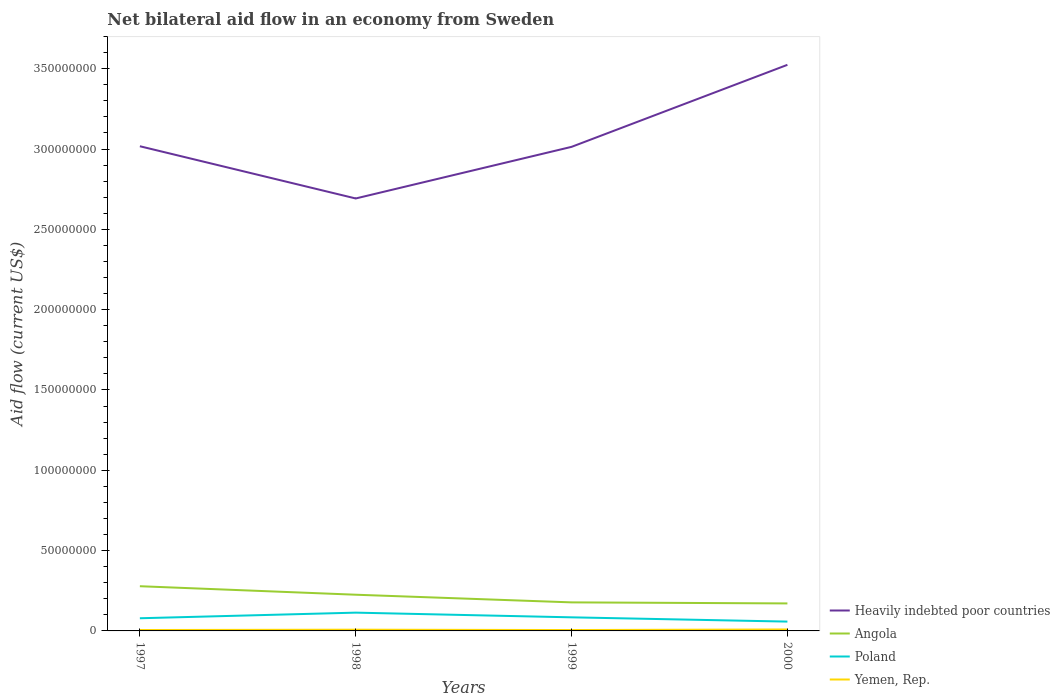Does the line corresponding to Heavily indebted poor countries intersect with the line corresponding to Angola?
Provide a succinct answer. No. Across all years, what is the maximum net bilateral aid flow in Angola?
Give a very brief answer. 1.71e+07. In which year was the net bilateral aid flow in Yemen, Rep. maximum?
Give a very brief answer. 1999. What is the total net bilateral aid flow in Angola in the graph?
Make the answer very short. 5.29e+06. What is the difference between the highest and the second highest net bilateral aid flow in Heavily indebted poor countries?
Provide a succinct answer. 8.32e+07. Is the net bilateral aid flow in Angola strictly greater than the net bilateral aid flow in Heavily indebted poor countries over the years?
Your answer should be compact. Yes. How many lines are there?
Provide a succinct answer. 4. Are the values on the major ticks of Y-axis written in scientific E-notation?
Give a very brief answer. No. Does the graph contain any zero values?
Offer a very short reply. No. Does the graph contain grids?
Keep it short and to the point. No. How are the legend labels stacked?
Offer a very short reply. Vertical. What is the title of the graph?
Your answer should be compact. Net bilateral aid flow in an economy from Sweden. What is the label or title of the X-axis?
Give a very brief answer. Years. What is the Aid flow (current US$) in Heavily indebted poor countries in 1997?
Keep it short and to the point. 3.02e+08. What is the Aid flow (current US$) of Angola in 1997?
Your answer should be compact. 2.78e+07. What is the Aid flow (current US$) in Poland in 1997?
Provide a succinct answer. 7.89e+06. What is the Aid flow (current US$) of Yemen, Rep. in 1997?
Your answer should be compact. 5.60e+05. What is the Aid flow (current US$) in Heavily indebted poor countries in 1998?
Keep it short and to the point. 2.69e+08. What is the Aid flow (current US$) of Angola in 1998?
Ensure brevity in your answer.  2.25e+07. What is the Aid flow (current US$) in Poland in 1998?
Your answer should be very brief. 1.14e+07. What is the Aid flow (current US$) in Yemen, Rep. in 1998?
Give a very brief answer. 7.70e+05. What is the Aid flow (current US$) of Heavily indebted poor countries in 1999?
Your response must be concise. 3.01e+08. What is the Aid flow (current US$) in Angola in 1999?
Ensure brevity in your answer.  1.78e+07. What is the Aid flow (current US$) of Poland in 1999?
Give a very brief answer. 8.46e+06. What is the Aid flow (current US$) in Yemen, Rep. in 1999?
Ensure brevity in your answer.  5.50e+05. What is the Aid flow (current US$) of Heavily indebted poor countries in 2000?
Provide a short and direct response. 3.52e+08. What is the Aid flow (current US$) of Angola in 2000?
Offer a terse response. 1.71e+07. What is the Aid flow (current US$) of Poland in 2000?
Your answer should be very brief. 5.81e+06. What is the Aid flow (current US$) in Yemen, Rep. in 2000?
Your answer should be very brief. 9.10e+05. Across all years, what is the maximum Aid flow (current US$) in Heavily indebted poor countries?
Your answer should be very brief. 3.52e+08. Across all years, what is the maximum Aid flow (current US$) of Angola?
Offer a terse response. 2.78e+07. Across all years, what is the maximum Aid flow (current US$) in Poland?
Offer a very short reply. 1.14e+07. Across all years, what is the maximum Aid flow (current US$) of Yemen, Rep.?
Ensure brevity in your answer.  9.10e+05. Across all years, what is the minimum Aid flow (current US$) of Heavily indebted poor countries?
Your answer should be compact. 2.69e+08. Across all years, what is the minimum Aid flow (current US$) in Angola?
Provide a succinct answer. 1.71e+07. Across all years, what is the minimum Aid flow (current US$) in Poland?
Your response must be concise. 5.81e+06. Across all years, what is the minimum Aid flow (current US$) in Yemen, Rep.?
Make the answer very short. 5.50e+05. What is the total Aid flow (current US$) in Heavily indebted poor countries in the graph?
Ensure brevity in your answer.  1.22e+09. What is the total Aid flow (current US$) in Angola in the graph?
Keep it short and to the point. 8.53e+07. What is the total Aid flow (current US$) of Poland in the graph?
Provide a succinct answer. 3.35e+07. What is the total Aid flow (current US$) of Yemen, Rep. in the graph?
Make the answer very short. 2.79e+06. What is the difference between the Aid flow (current US$) of Heavily indebted poor countries in 1997 and that in 1998?
Offer a very short reply. 3.25e+07. What is the difference between the Aid flow (current US$) of Angola in 1997 and that in 1998?
Ensure brevity in your answer.  5.29e+06. What is the difference between the Aid flow (current US$) of Poland in 1997 and that in 1998?
Your answer should be very brief. -3.49e+06. What is the difference between the Aid flow (current US$) in Yemen, Rep. in 1997 and that in 1998?
Provide a short and direct response. -2.10e+05. What is the difference between the Aid flow (current US$) of Angola in 1997 and that in 1999?
Keep it short and to the point. 1.01e+07. What is the difference between the Aid flow (current US$) of Poland in 1997 and that in 1999?
Your answer should be very brief. -5.70e+05. What is the difference between the Aid flow (current US$) of Heavily indebted poor countries in 1997 and that in 2000?
Keep it short and to the point. -5.07e+07. What is the difference between the Aid flow (current US$) in Angola in 1997 and that in 2000?
Your response must be concise. 1.07e+07. What is the difference between the Aid flow (current US$) in Poland in 1997 and that in 2000?
Your answer should be very brief. 2.08e+06. What is the difference between the Aid flow (current US$) in Yemen, Rep. in 1997 and that in 2000?
Ensure brevity in your answer.  -3.50e+05. What is the difference between the Aid flow (current US$) of Heavily indebted poor countries in 1998 and that in 1999?
Your response must be concise. -3.21e+07. What is the difference between the Aid flow (current US$) of Angola in 1998 and that in 1999?
Your answer should be compact. 4.77e+06. What is the difference between the Aid flow (current US$) of Poland in 1998 and that in 1999?
Your answer should be compact. 2.92e+06. What is the difference between the Aid flow (current US$) of Heavily indebted poor countries in 1998 and that in 2000?
Your answer should be compact. -8.32e+07. What is the difference between the Aid flow (current US$) in Angola in 1998 and that in 2000?
Ensure brevity in your answer.  5.42e+06. What is the difference between the Aid flow (current US$) in Poland in 1998 and that in 2000?
Make the answer very short. 5.57e+06. What is the difference between the Aid flow (current US$) of Heavily indebted poor countries in 1999 and that in 2000?
Keep it short and to the point. -5.11e+07. What is the difference between the Aid flow (current US$) of Angola in 1999 and that in 2000?
Your answer should be compact. 6.50e+05. What is the difference between the Aid flow (current US$) of Poland in 1999 and that in 2000?
Offer a terse response. 2.65e+06. What is the difference between the Aid flow (current US$) of Yemen, Rep. in 1999 and that in 2000?
Offer a very short reply. -3.60e+05. What is the difference between the Aid flow (current US$) of Heavily indebted poor countries in 1997 and the Aid flow (current US$) of Angola in 1998?
Your response must be concise. 2.79e+08. What is the difference between the Aid flow (current US$) in Heavily indebted poor countries in 1997 and the Aid flow (current US$) in Poland in 1998?
Ensure brevity in your answer.  2.90e+08. What is the difference between the Aid flow (current US$) in Heavily indebted poor countries in 1997 and the Aid flow (current US$) in Yemen, Rep. in 1998?
Your answer should be very brief. 3.01e+08. What is the difference between the Aid flow (current US$) of Angola in 1997 and the Aid flow (current US$) of Poland in 1998?
Your response must be concise. 1.64e+07. What is the difference between the Aid flow (current US$) of Angola in 1997 and the Aid flow (current US$) of Yemen, Rep. in 1998?
Your response must be concise. 2.71e+07. What is the difference between the Aid flow (current US$) in Poland in 1997 and the Aid flow (current US$) in Yemen, Rep. in 1998?
Provide a short and direct response. 7.12e+06. What is the difference between the Aid flow (current US$) of Heavily indebted poor countries in 1997 and the Aid flow (current US$) of Angola in 1999?
Keep it short and to the point. 2.84e+08. What is the difference between the Aid flow (current US$) of Heavily indebted poor countries in 1997 and the Aid flow (current US$) of Poland in 1999?
Provide a succinct answer. 2.93e+08. What is the difference between the Aid flow (current US$) in Heavily indebted poor countries in 1997 and the Aid flow (current US$) in Yemen, Rep. in 1999?
Give a very brief answer. 3.01e+08. What is the difference between the Aid flow (current US$) in Angola in 1997 and the Aid flow (current US$) in Poland in 1999?
Provide a short and direct response. 1.94e+07. What is the difference between the Aid flow (current US$) of Angola in 1997 and the Aid flow (current US$) of Yemen, Rep. in 1999?
Offer a terse response. 2.73e+07. What is the difference between the Aid flow (current US$) of Poland in 1997 and the Aid flow (current US$) of Yemen, Rep. in 1999?
Make the answer very short. 7.34e+06. What is the difference between the Aid flow (current US$) of Heavily indebted poor countries in 1997 and the Aid flow (current US$) of Angola in 2000?
Make the answer very short. 2.85e+08. What is the difference between the Aid flow (current US$) in Heavily indebted poor countries in 1997 and the Aid flow (current US$) in Poland in 2000?
Give a very brief answer. 2.96e+08. What is the difference between the Aid flow (current US$) of Heavily indebted poor countries in 1997 and the Aid flow (current US$) of Yemen, Rep. in 2000?
Your answer should be compact. 3.01e+08. What is the difference between the Aid flow (current US$) of Angola in 1997 and the Aid flow (current US$) of Poland in 2000?
Your answer should be very brief. 2.20e+07. What is the difference between the Aid flow (current US$) of Angola in 1997 and the Aid flow (current US$) of Yemen, Rep. in 2000?
Your answer should be compact. 2.69e+07. What is the difference between the Aid flow (current US$) in Poland in 1997 and the Aid flow (current US$) in Yemen, Rep. in 2000?
Make the answer very short. 6.98e+06. What is the difference between the Aid flow (current US$) in Heavily indebted poor countries in 1998 and the Aid flow (current US$) in Angola in 1999?
Keep it short and to the point. 2.51e+08. What is the difference between the Aid flow (current US$) of Heavily indebted poor countries in 1998 and the Aid flow (current US$) of Poland in 1999?
Offer a terse response. 2.61e+08. What is the difference between the Aid flow (current US$) of Heavily indebted poor countries in 1998 and the Aid flow (current US$) of Yemen, Rep. in 1999?
Offer a very short reply. 2.69e+08. What is the difference between the Aid flow (current US$) in Angola in 1998 and the Aid flow (current US$) in Poland in 1999?
Provide a succinct answer. 1.41e+07. What is the difference between the Aid flow (current US$) in Angola in 1998 and the Aid flow (current US$) in Yemen, Rep. in 1999?
Your answer should be very brief. 2.20e+07. What is the difference between the Aid flow (current US$) of Poland in 1998 and the Aid flow (current US$) of Yemen, Rep. in 1999?
Give a very brief answer. 1.08e+07. What is the difference between the Aid flow (current US$) in Heavily indebted poor countries in 1998 and the Aid flow (current US$) in Angola in 2000?
Make the answer very short. 2.52e+08. What is the difference between the Aid flow (current US$) in Heavily indebted poor countries in 1998 and the Aid flow (current US$) in Poland in 2000?
Your answer should be very brief. 2.63e+08. What is the difference between the Aid flow (current US$) of Heavily indebted poor countries in 1998 and the Aid flow (current US$) of Yemen, Rep. in 2000?
Give a very brief answer. 2.68e+08. What is the difference between the Aid flow (current US$) of Angola in 1998 and the Aid flow (current US$) of Poland in 2000?
Your response must be concise. 1.67e+07. What is the difference between the Aid flow (current US$) in Angola in 1998 and the Aid flow (current US$) in Yemen, Rep. in 2000?
Give a very brief answer. 2.16e+07. What is the difference between the Aid flow (current US$) of Poland in 1998 and the Aid flow (current US$) of Yemen, Rep. in 2000?
Provide a succinct answer. 1.05e+07. What is the difference between the Aid flow (current US$) of Heavily indebted poor countries in 1999 and the Aid flow (current US$) of Angola in 2000?
Offer a very short reply. 2.84e+08. What is the difference between the Aid flow (current US$) in Heavily indebted poor countries in 1999 and the Aid flow (current US$) in Poland in 2000?
Give a very brief answer. 2.96e+08. What is the difference between the Aid flow (current US$) in Heavily indebted poor countries in 1999 and the Aid flow (current US$) in Yemen, Rep. in 2000?
Your answer should be very brief. 3.00e+08. What is the difference between the Aid flow (current US$) in Angola in 1999 and the Aid flow (current US$) in Poland in 2000?
Your response must be concise. 1.20e+07. What is the difference between the Aid flow (current US$) in Angola in 1999 and the Aid flow (current US$) in Yemen, Rep. in 2000?
Your answer should be very brief. 1.69e+07. What is the difference between the Aid flow (current US$) of Poland in 1999 and the Aid flow (current US$) of Yemen, Rep. in 2000?
Offer a very short reply. 7.55e+06. What is the average Aid flow (current US$) of Heavily indebted poor countries per year?
Provide a short and direct response. 3.06e+08. What is the average Aid flow (current US$) in Angola per year?
Ensure brevity in your answer.  2.13e+07. What is the average Aid flow (current US$) in Poland per year?
Provide a succinct answer. 8.38e+06. What is the average Aid flow (current US$) of Yemen, Rep. per year?
Make the answer very short. 6.98e+05. In the year 1997, what is the difference between the Aid flow (current US$) in Heavily indebted poor countries and Aid flow (current US$) in Angola?
Provide a succinct answer. 2.74e+08. In the year 1997, what is the difference between the Aid flow (current US$) of Heavily indebted poor countries and Aid flow (current US$) of Poland?
Keep it short and to the point. 2.94e+08. In the year 1997, what is the difference between the Aid flow (current US$) of Heavily indebted poor countries and Aid flow (current US$) of Yemen, Rep.?
Your answer should be very brief. 3.01e+08. In the year 1997, what is the difference between the Aid flow (current US$) of Angola and Aid flow (current US$) of Poland?
Your answer should be very brief. 1.99e+07. In the year 1997, what is the difference between the Aid flow (current US$) of Angola and Aid flow (current US$) of Yemen, Rep.?
Provide a short and direct response. 2.73e+07. In the year 1997, what is the difference between the Aid flow (current US$) in Poland and Aid flow (current US$) in Yemen, Rep.?
Ensure brevity in your answer.  7.33e+06. In the year 1998, what is the difference between the Aid flow (current US$) in Heavily indebted poor countries and Aid flow (current US$) in Angola?
Offer a terse response. 2.47e+08. In the year 1998, what is the difference between the Aid flow (current US$) in Heavily indebted poor countries and Aid flow (current US$) in Poland?
Provide a short and direct response. 2.58e+08. In the year 1998, what is the difference between the Aid flow (current US$) in Heavily indebted poor countries and Aid flow (current US$) in Yemen, Rep.?
Your answer should be very brief. 2.68e+08. In the year 1998, what is the difference between the Aid flow (current US$) of Angola and Aid flow (current US$) of Poland?
Ensure brevity in your answer.  1.12e+07. In the year 1998, what is the difference between the Aid flow (current US$) in Angola and Aid flow (current US$) in Yemen, Rep.?
Offer a terse response. 2.18e+07. In the year 1998, what is the difference between the Aid flow (current US$) of Poland and Aid flow (current US$) of Yemen, Rep.?
Keep it short and to the point. 1.06e+07. In the year 1999, what is the difference between the Aid flow (current US$) in Heavily indebted poor countries and Aid flow (current US$) in Angola?
Keep it short and to the point. 2.84e+08. In the year 1999, what is the difference between the Aid flow (current US$) in Heavily indebted poor countries and Aid flow (current US$) in Poland?
Provide a succinct answer. 2.93e+08. In the year 1999, what is the difference between the Aid flow (current US$) of Heavily indebted poor countries and Aid flow (current US$) of Yemen, Rep.?
Keep it short and to the point. 3.01e+08. In the year 1999, what is the difference between the Aid flow (current US$) of Angola and Aid flow (current US$) of Poland?
Your answer should be very brief. 9.31e+06. In the year 1999, what is the difference between the Aid flow (current US$) of Angola and Aid flow (current US$) of Yemen, Rep.?
Make the answer very short. 1.72e+07. In the year 1999, what is the difference between the Aid flow (current US$) in Poland and Aid flow (current US$) in Yemen, Rep.?
Your answer should be compact. 7.91e+06. In the year 2000, what is the difference between the Aid flow (current US$) in Heavily indebted poor countries and Aid flow (current US$) in Angola?
Provide a succinct answer. 3.35e+08. In the year 2000, what is the difference between the Aid flow (current US$) of Heavily indebted poor countries and Aid flow (current US$) of Poland?
Your answer should be compact. 3.47e+08. In the year 2000, what is the difference between the Aid flow (current US$) in Heavily indebted poor countries and Aid flow (current US$) in Yemen, Rep.?
Your response must be concise. 3.52e+08. In the year 2000, what is the difference between the Aid flow (current US$) in Angola and Aid flow (current US$) in Poland?
Provide a succinct answer. 1.13e+07. In the year 2000, what is the difference between the Aid flow (current US$) of Angola and Aid flow (current US$) of Yemen, Rep.?
Keep it short and to the point. 1.62e+07. In the year 2000, what is the difference between the Aid flow (current US$) in Poland and Aid flow (current US$) in Yemen, Rep.?
Offer a very short reply. 4.90e+06. What is the ratio of the Aid flow (current US$) in Heavily indebted poor countries in 1997 to that in 1998?
Keep it short and to the point. 1.12. What is the ratio of the Aid flow (current US$) in Angola in 1997 to that in 1998?
Your answer should be compact. 1.23. What is the ratio of the Aid flow (current US$) in Poland in 1997 to that in 1998?
Provide a succinct answer. 0.69. What is the ratio of the Aid flow (current US$) in Yemen, Rep. in 1997 to that in 1998?
Keep it short and to the point. 0.73. What is the ratio of the Aid flow (current US$) of Angola in 1997 to that in 1999?
Your answer should be compact. 1.57. What is the ratio of the Aid flow (current US$) of Poland in 1997 to that in 1999?
Keep it short and to the point. 0.93. What is the ratio of the Aid flow (current US$) of Yemen, Rep. in 1997 to that in 1999?
Keep it short and to the point. 1.02. What is the ratio of the Aid flow (current US$) in Heavily indebted poor countries in 1997 to that in 2000?
Give a very brief answer. 0.86. What is the ratio of the Aid flow (current US$) in Angola in 1997 to that in 2000?
Ensure brevity in your answer.  1.63. What is the ratio of the Aid flow (current US$) in Poland in 1997 to that in 2000?
Offer a terse response. 1.36. What is the ratio of the Aid flow (current US$) in Yemen, Rep. in 1997 to that in 2000?
Your response must be concise. 0.62. What is the ratio of the Aid flow (current US$) of Heavily indebted poor countries in 1998 to that in 1999?
Keep it short and to the point. 0.89. What is the ratio of the Aid flow (current US$) in Angola in 1998 to that in 1999?
Ensure brevity in your answer.  1.27. What is the ratio of the Aid flow (current US$) of Poland in 1998 to that in 1999?
Give a very brief answer. 1.35. What is the ratio of the Aid flow (current US$) in Heavily indebted poor countries in 1998 to that in 2000?
Make the answer very short. 0.76. What is the ratio of the Aid flow (current US$) in Angola in 1998 to that in 2000?
Provide a short and direct response. 1.32. What is the ratio of the Aid flow (current US$) in Poland in 1998 to that in 2000?
Your response must be concise. 1.96. What is the ratio of the Aid flow (current US$) in Yemen, Rep. in 1998 to that in 2000?
Your answer should be compact. 0.85. What is the ratio of the Aid flow (current US$) in Heavily indebted poor countries in 1999 to that in 2000?
Give a very brief answer. 0.86. What is the ratio of the Aid flow (current US$) of Angola in 1999 to that in 2000?
Your answer should be compact. 1.04. What is the ratio of the Aid flow (current US$) of Poland in 1999 to that in 2000?
Your answer should be very brief. 1.46. What is the ratio of the Aid flow (current US$) in Yemen, Rep. in 1999 to that in 2000?
Make the answer very short. 0.6. What is the difference between the highest and the second highest Aid flow (current US$) in Heavily indebted poor countries?
Offer a very short reply. 5.07e+07. What is the difference between the highest and the second highest Aid flow (current US$) of Angola?
Offer a very short reply. 5.29e+06. What is the difference between the highest and the second highest Aid flow (current US$) of Poland?
Provide a succinct answer. 2.92e+06. What is the difference between the highest and the lowest Aid flow (current US$) in Heavily indebted poor countries?
Ensure brevity in your answer.  8.32e+07. What is the difference between the highest and the lowest Aid flow (current US$) of Angola?
Offer a very short reply. 1.07e+07. What is the difference between the highest and the lowest Aid flow (current US$) in Poland?
Give a very brief answer. 5.57e+06. 